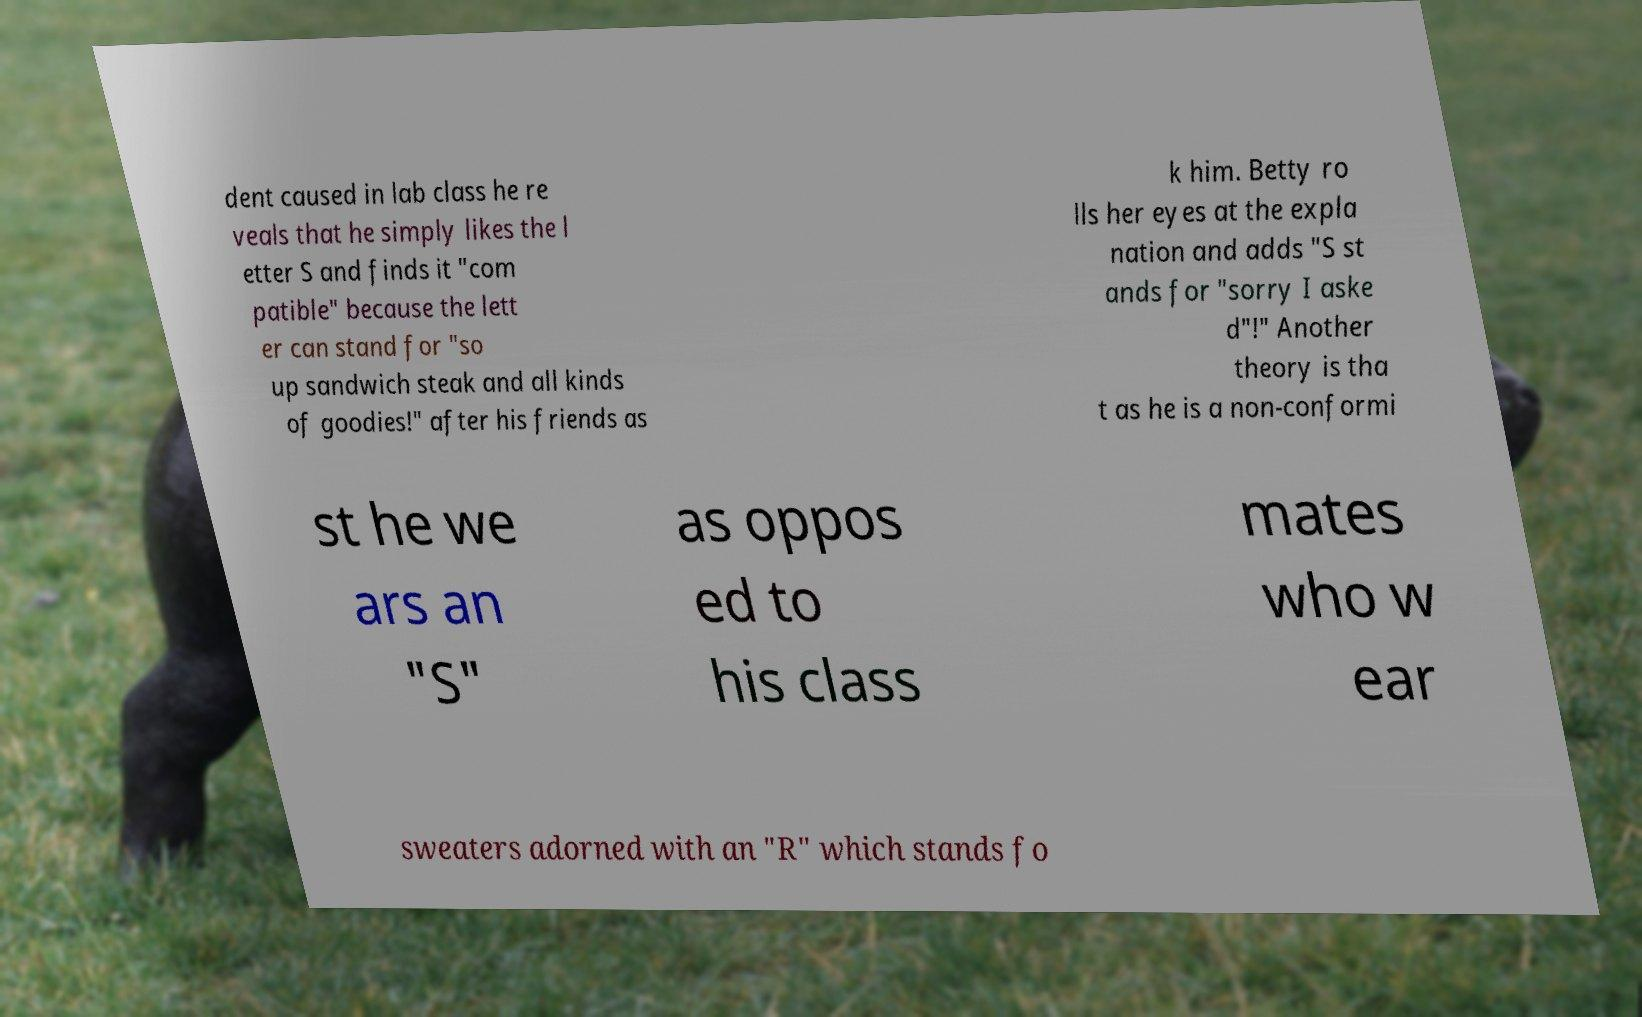Could you assist in decoding the text presented in this image and type it out clearly? dent caused in lab class he re veals that he simply likes the l etter S and finds it "com patible" because the lett er can stand for "so up sandwich steak and all kinds of goodies!" after his friends as k him. Betty ro lls her eyes at the expla nation and adds "S st ands for "sorry I aske d"!" Another theory is tha t as he is a non-conformi st he we ars an "S" as oppos ed to his class mates who w ear sweaters adorned with an "R" which stands fo 